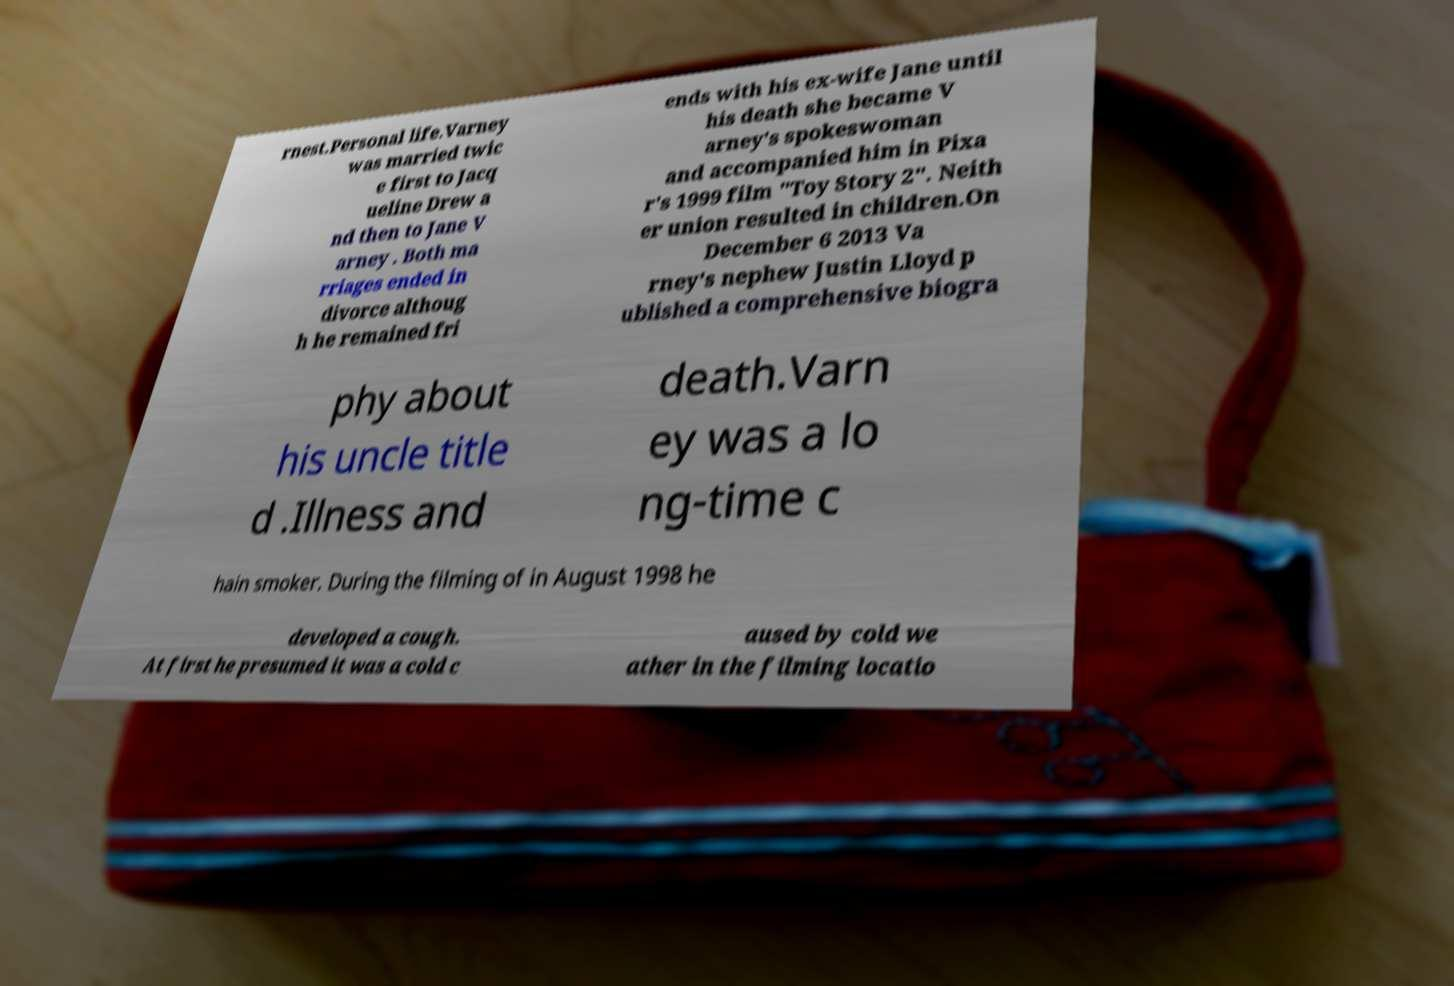For documentation purposes, I need the text within this image transcribed. Could you provide that? rnest.Personal life.Varney was married twic e first to Jacq ueline Drew a nd then to Jane V arney . Both ma rriages ended in divorce althoug h he remained fri ends with his ex-wife Jane until his death she became V arney's spokeswoman and accompanied him in Pixa r's 1999 film "Toy Story 2". Neith er union resulted in children.On December 6 2013 Va rney's nephew Justin Lloyd p ublished a comprehensive biogra phy about his uncle title d .Illness and death.Varn ey was a lo ng-time c hain smoker. During the filming of in August 1998 he developed a cough. At first he presumed it was a cold c aused by cold we ather in the filming locatio 